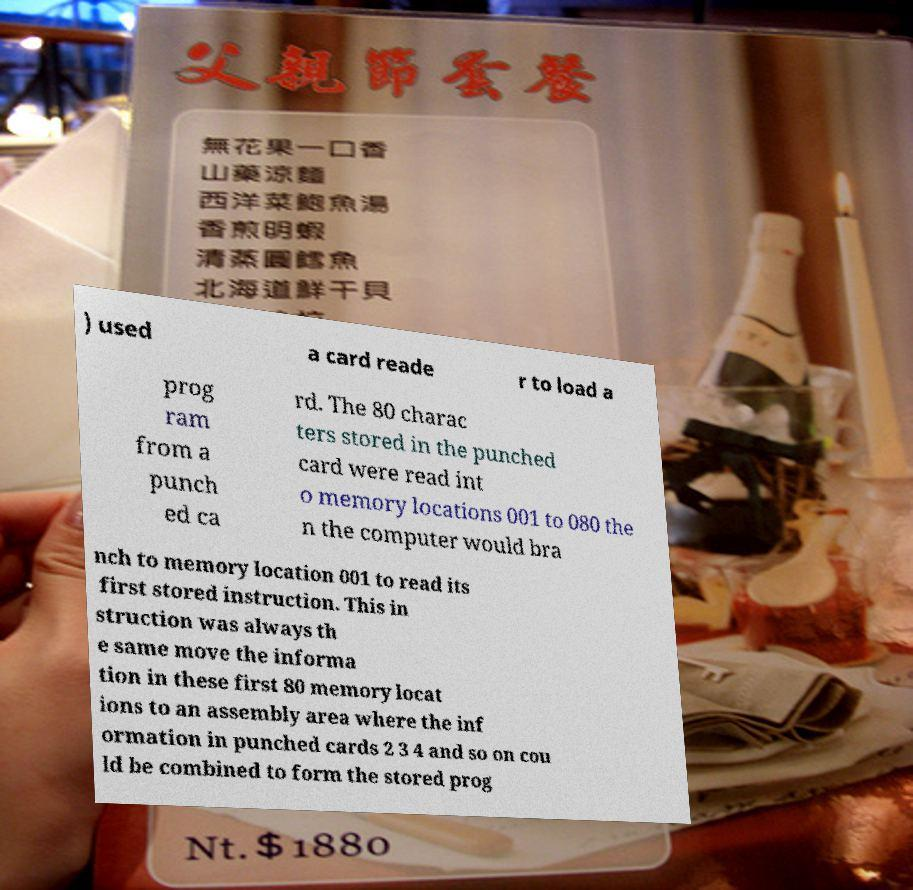Could you extract and type out the text from this image? ) used a card reade r to load a prog ram from a punch ed ca rd. The 80 charac ters stored in the punched card were read int o memory locations 001 to 080 the n the computer would bra nch to memory location 001 to read its first stored instruction. This in struction was always th e same move the informa tion in these first 80 memory locat ions to an assembly area where the inf ormation in punched cards 2 3 4 and so on cou ld be combined to form the stored prog 